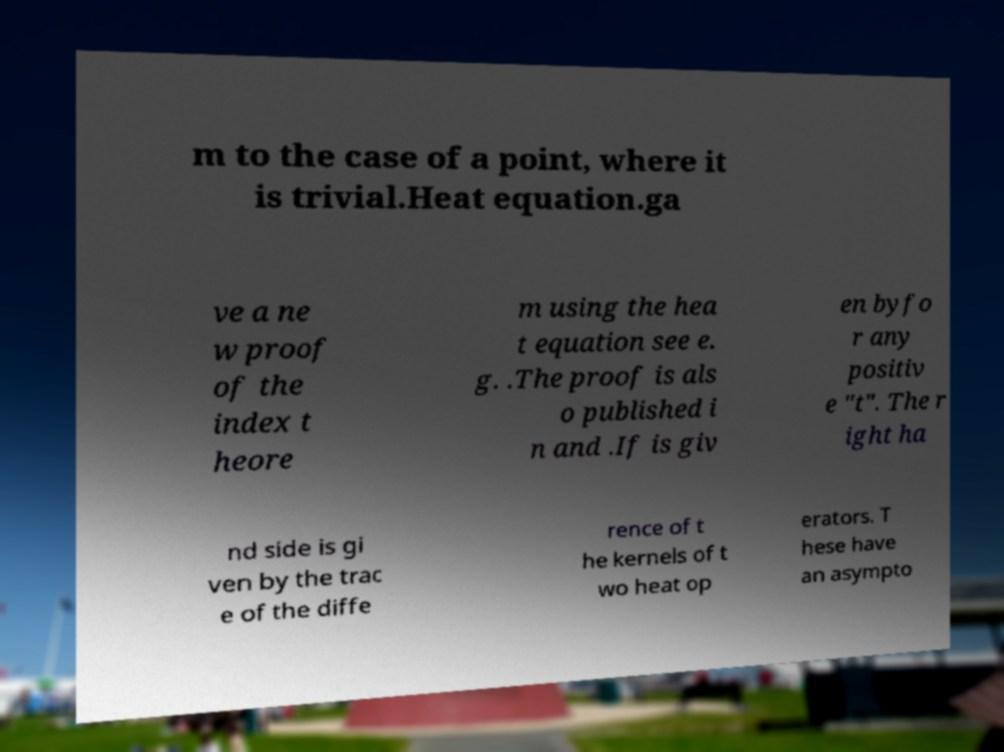Could you extract and type out the text from this image? m to the case of a point, where it is trivial.Heat equation.ga ve a ne w proof of the index t heore m using the hea t equation see e. g. .The proof is als o published i n and .If is giv en byfo r any positiv e "t". The r ight ha nd side is gi ven by the trac e of the diffe rence of t he kernels of t wo heat op erators. T hese have an asympto 